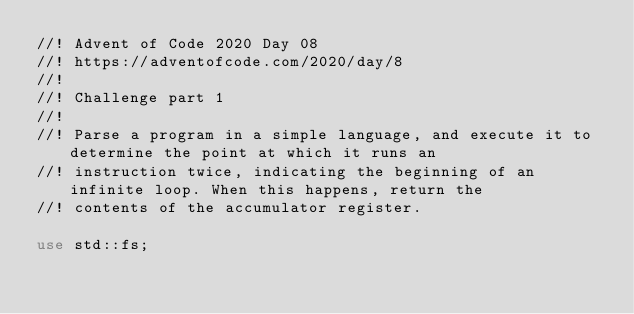<code> <loc_0><loc_0><loc_500><loc_500><_Rust_>//! Advent of Code 2020 Day 08
//! https://adventofcode.com/2020/day/8
//!
//! Challenge part 1
//!
//! Parse a program in a simple language, and execute it to determine the point at which it runs an
//! instruction twice, indicating the beginning of an infinite loop. When this happens, return the
//! contents of the accumulator register.

use std::fs;
</code> 